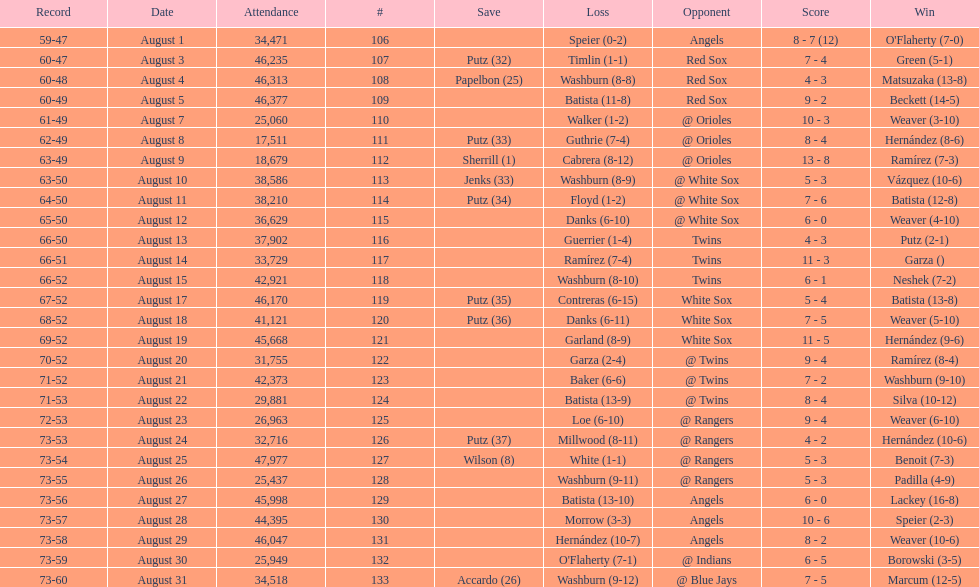How many losses during stretch? 7. Would you mind parsing the complete table? {'header': ['Record', 'Date', 'Attendance', '#', 'Save', 'Loss', 'Opponent', 'Score', 'Win'], 'rows': [['59-47', 'August 1', '34,471', '106', '', 'Speier (0-2)', 'Angels', '8 - 7 (12)', "O'Flaherty (7-0)"], ['60-47', 'August 3', '46,235', '107', 'Putz (32)', 'Timlin (1-1)', 'Red Sox', '7 - 4', 'Green (5-1)'], ['60-48', 'August 4', '46,313', '108', 'Papelbon (25)', 'Washburn (8-8)', 'Red Sox', '4 - 3', 'Matsuzaka (13-8)'], ['60-49', 'August 5', '46,377', '109', '', 'Batista (11-8)', 'Red Sox', '9 - 2', 'Beckett (14-5)'], ['61-49', 'August 7', '25,060', '110', '', 'Walker (1-2)', '@ Orioles', '10 - 3', 'Weaver (3-10)'], ['62-49', 'August 8', '17,511', '111', 'Putz (33)', 'Guthrie (7-4)', '@ Orioles', '8 - 4', 'Hernández (8-6)'], ['63-49', 'August 9', '18,679', '112', 'Sherrill (1)', 'Cabrera (8-12)', '@ Orioles', '13 - 8', 'Ramírez (7-3)'], ['63-50', 'August 10', '38,586', '113', 'Jenks (33)', 'Washburn (8-9)', '@ White Sox', '5 - 3', 'Vázquez (10-6)'], ['64-50', 'August 11', '38,210', '114', 'Putz (34)', 'Floyd (1-2)', '@ White Sox', '7 - 6', 'Batista (12-8)'], ['65-50', 'August 12', '36,629', '115', '', 'Danks (6-10)', '@ White Sox', '6 - 0', 'Weaver (4-10)'], ['66-50', 'August 13', '37,902', '116', '', 'Guerrier (1-4)', 'Twins', '4 - 3', 'Putz (2-1)'], ['66-51', 'August 14', '33,729', '117', '', 'Ramírez (7-4)', 'Twins', '11 - 3', 'Garza ()'], ['66-52', 'August 15', '42,921', '118', '', 'Washburn (8-10)', 'Twins', '6 - 1', 'Neshek (7-2)'], ['67-52', 'August 17', '46,170', '119', 'Putz (35)', 'Contreras (6-15)', 'White Sox', '5 - 4', 'Batista (13-8)'], ['68-52', 'August 18', '41,121', '120', 'Putz (36)', 'Danks (6-11)', 'White Sox', '7 - 5', 'Weaver (5-10)'], ['69-52', 'August 19', '45,668', '121', '', 'Garland (8-9)', 'White Sox', '11 - 5', 'Hernández (9-6)'], ['70-52', 'August 20', '31,755', '122', '', 'Garza (2-4)', '@ Twins', '9 - 4', 'Ramírez (8-4)'], ['71-52', 'August 21', '42,373', '123', '', 'Baker (6-6)', '@ Twins', '7 - 2', 'Washburn (9-10)'], ['71-53', 'August 22', '29,881', '124', '', 'Batista (13-9)', '@ Twins', '8 - 4', 'Silva (10-12)'], ['72-53', 'August 23', '26,963', '125', '', 'Loe (6-10)', '@ Rangers', '9 - 4', 'Weaver (6-10)'], ['73-53', 'August 24', '32,716', '126', 'Putz (37)', 'Millwood (8-11)', '@ Rangers', '4 - 2', 'Hernández (10-6)'], ['73-54', 'August 25', '47,977', '127', 'Wilson (8)', 'White (1-1)', '@ Rangers', '5 - 3', 'Benoit (7-3)'], ['73-55', 'August 26', '25,437', '128', '', 'Washburn (9-11)', '@ Rangers', '5 - 3', 'Padilla (4-9)'], ['73-56', 'August 27', '45,998', '129', '', 'Batista (13-10)', 'Angels', '6 - 0', 'Lackey (16-8)'], ['73-57', 'August 28', '44,395', '130', '', 'Morrow (3-3)', 'Angels', '10 - 6', 'Speier (2-3)'], ['73-58', 'August 29', '46,047', '131', '', 'Hernández (10-7)', 'Angels', '8 - 2', 'Weaver (10-6)'], ['73-59', 'August 30', '25,949', '132', '', "O'Flaherty (7-1)", '@ Indians', '6 - 5', 'Borowski (3-5)'], ['73-60', 'August 31', '34,518', '133', 'Accardo (26)', 'Washburn (9-12)', '@ Blue Jays', '7 - 5', 'Marcum (12-5)']]} 